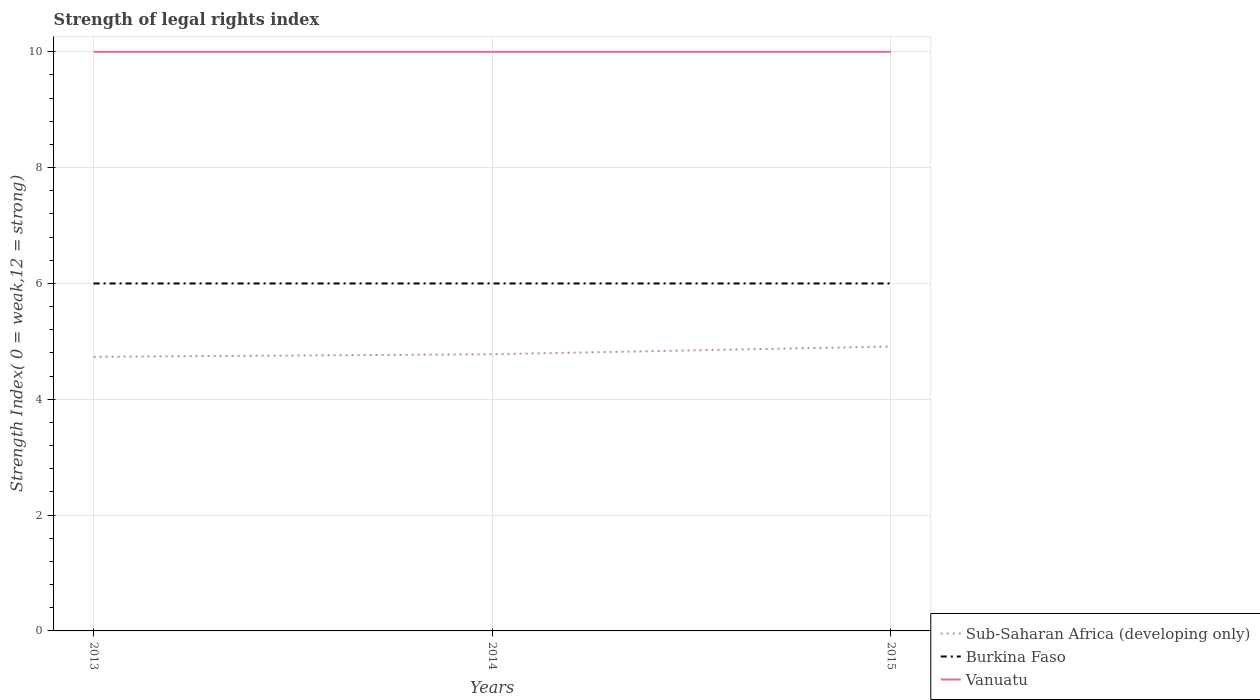Does the line corresponding to Burkina Faso intersect with the line corresponding to Sub-Saharan Africa (developing only)?
Give a very brief answer. No. Is the number of lines equal to the number of legend labels?
Offer a terse response. Yes. In which year was the strength index in Sub-Saharan Africa (developing only) maximum?
Your answer should be compact. 2013. What is the total strength index in Sub-Saharan Africa (developing only) in the graph?
Keep it short and to the point. -0.13. What is the difference between the highest and the second highest strength index in Burkina Faso?
Ensure brevity in your answer.  0. Is the strength index in Burkina Faso strictly greater than the strength index in Sub-Saharan Africa (developing only) over the years?
Provide a succinct answer. No. How many years are there in the graph?
Make the answer very short. 3. What is the difference between two consecutive major ticks on the Y-axis?
Offer a very short reply. 2. Are the values on the major ticks of Y-axis written in scientific E-notation?
Keep it short and to the point. No. Where does the legend appear in the graph?
Your answer should be very brief. Bottom right. How many legend labels are there?
Keep it short and to the point. 3. What is the title of the graph?
Offer a terse response. Strength of legal rights index. Does "Nepal" appear as one of the legend labels in the graph?
Provide a short and direct response. No. What is the label or title of the Y-axis?
Your answer should be very brief. Strength Index( 0 = weak,12 = strong). What is the Strength Index( 0 = weak,12 = strong) of Sub-Saharan Africa (developing only) in 2013?
Your answer should be very brief. 4.73. What is the Strength Index( 0 = weak,12 = strong) of Sub-Saharan Africa (developing only) in 2014?
Make the answer very short. 4.78. What is the Strength Index( 0 = weak,12 = strong) of Burkina Faso in 2014?
Offer a terse response. 6. What is the Strength Index( 0 = weak,12 = strong) of Vanuatu in 2014?
Your response must be concise. 10. What is the Strength Index( 0 = weak,12 = strong) of Sub-Saharan Africa (developing only) in 2015?
Keep it short and to the point. 4.91. What is the Strength Index( 0 = weak,12 = strong) of Burkina Faso in 2015?
Offer a terse response. 6. What is the Strength Index( 0 = weak,12 = strong) of Vanuatu in 2015?
Provide a short and direct response. 10. Across all years, what is the maximum Strength Index( 0 = weak,12 = strong) of Sub-Saharan Africa (developing only)?
Offer a terse response. 4.91. Across all years, what is the maximum Strength Index( 0 = weak,12 = strong) of Vanuatu?
Offer a terse response. 10. Across all years, what is the minimum Strength Index( 0 = weak,12 = strong) of Sub-Saharan Africa (developing only)?
Keep it short and to the point. 4.73. Across all years, what is the minimum Strength Index( 0 = weak,12 = strong) in Burkina Faso?
Ensure brevity in your answer.  6. What is the total Strength Index( 0 = weak,12 = strong) in Sub-Saharan Africa (developing only) in the graph?
Provide a succinct answer. 14.42. What is the total Strength Index( 0 = weak,12 = strong) of Vanuatu in the graph?
Offer a terse response. 30. What is the difference between the Strength Index( 0 = weak,12 = strong) in Sub-Saharan Africa (developing only) in 2013 and that in 2014?
Make the answer very short. -0.04. What is the difference between the Strength Index( 0 = weak,12 = strong) in Burkina Faso in 2013 and that in 2014?
Offer a very short reply. 0. What is the difference between the Strength Index( 0 = weak,12 = strong) of Vanuatu in 2013 and that in 2014?
Provide a succinct answer. 0. What is the difference between the Strength Index( 0 = weak,12 = strong) in Sub-Saharan Africa (developing only) in 2013 and that in 2015?
Offer a terse response. -0.18. What is the difference between the Strength Index( 0 = weak,12 = strong) in Burkina Faso in 2013 and that in 2015?
Your answer should be compact. 0. What is the difference between the Strength Index( 0 = weak,12 = strong) in Vanuatu in 2013 and that in 2015?
Provide a succinct answer. 0. What is the difference between the Strength Index( 0 = weak,12 = strong) of Sub-Saharan Africa (developing only) in 2014 and that in 2015?
Provide a short and direct response. -0.13. What is the difference between the Strength Index( 0 = weak,12 = strong) of Vanuatu in 2014 and that in 2015?
Provide a succinct answer. 0. What is the difference between the Strength Index( 0 = weak,12 = strong) in Sub-Saharan Africa (developing only) in 2013 and the Strength Index( 0 = weak,12 = strong) in Burkina Faso in 2014?
Ensure brevity in your answer.  -1.27. What is the difference between the Strength Index( 0 = weak,12 = strong) in Sub-Saharan Africa (developing only) in 2013 and the Strength Index( 0 = weak,12 = strong) in Vanuatu in 2014?
Offer a very short reply. -5.27. What is the difference between the Strength Index( 0 = weak,12 = strong) of Burkina Faso in 2013 and the Strength Index( 0 = weak,12 = strong) of Vanuatu in 2014?
Give a very brief answer. -4. What is the difference between the Strength Index( 0 = weak,12 = strong) of Sub-Saharan Africa (developing only) in 2013 and the Strength Index( 0 = weak,12 = strong) of Burkina Faso in 2015?
Give a very brief answer. -1.27. What is the difference between the Strength Index( 0 = weak,12 = strong) of Sub-Saharan Africa (developing only) in 2013 and the Strength Index( 0 = weak,12 = strong) of Vanuatu in 2015?
Offer a very short reply. -5.27. What is the difference between the Strength Index( 0 = weak,12 = strong) of Burkina Faso in 2013 and the Strength Index( 0 = weak,12 = strong) of Vanuatu in 2015?
Offer a terse response. -4. What is the difference between the Strength Index( 0 = weak,12 = strong) in Sub-Saharan Africa (developing only) in 2014 and the Strength Index( 0 = weak,12 = strong) in Burkina Faso in 2015?
Your answer should be compact. -1.22. What is the difference between the Strength Index( 0 = weak,12 = strong) of Sub-Saharan Africa (developing only) in 2014 and the Strength Index( 0 = weak,12 = strong) of Vanuatu in 2015?
Your response must be concise. -5.22. What is the difference between the Strength Index( 0 = weak,12 = strong) in Burkina Faso in 2014 and the Strength Index( 0 = weak,12 = strong) in Vanuatu in 2015?
Your answer should be compact. -4. What is the average Strength Index( 0 = weak,12 = strong) in Sub-Saharan Africa (developing only) per year?
Offer a terse response. 4.81. In the year 2013, what is the difference between the Strength Index( 0 = weak,12 = strong) of Sub-Saharan Africa (developing only) and Strength Index( 0 = weak,12 = strong) of Burkina Faso?
Keep it short and to the point. -1.27. In the year 2013, what is the difference between the Strength Index( 0 = weak,12 = strong) of Sub-Saharan Africa (developing only) and Strength Index( 0 = weak,12 = strong) of Vanuatu?
Offer a terse response. -5.27. In the year 2013, what is the difference between the Strength Index( 0 = weak,12 = strong) in Burkina Faso and Strength Index( 0 = weak,12 = strong) in Vanuatu?
Your response must be concise. -4. In the year 2014, what is the difference between the Strength Index( 0 = weak,12 = strong) of Sub-Saharan Africa (developing only) and Strength Index( 0 = weak,12 = strong) of Burkina Faso?
Keep it short and to the point. -1.22. In the year 2014, what is the difference between the Strength Index( 0 = weak,12 = strong) of Sub-Saharan Africa (developing only) and Strength Index( 0 = weak,12 = strong) of Vanuatu?
Ensure brevity in your answer.  -5.22. In the year 2015, what is the difference between the Strength Index( 0 = weak,12 = strong) of Sub-Saharan Africa (developing only) and Strength Index( 0 = weak,12 = strong) of Burkina Faso?
Give a very brief answer. -1.09. In the year 2015, what is the difference between the Strength Index( 0 = weak,12 = strong) of Sub-Saharan Africa (developing only) and Strength Index( 0 = weak,12 = strong) of Vanuatu?
Make the answer very short. -5.09. In the year 2015, what is the difference between the Strength Index( 0 = weak,12 = strong) in Burkina Faso and Strength Index( 0 = weak,12 = strong) in Vanuatu?
Your answer should be compact. -4. What is the ratio of the Strength Index( 0 = weak,12 = strong) of Sub-Saharan Africa (developing only) in 2013 to that in 2014?
Give a very brief answer. 0.99. What is the ratio of the Strength Index( 0 = weak,12 = strong) in Burkina Faso in 2013 to that in 2014?
Your answer should be compact. 1. What is the ratio of the Strength Index( 0 = weak,12 = strong) of Sub-Saharan Africa (developing only) in 2013 to that in 2015?
Your answer should be very brief. 0.96. What is the ratio of the Strength Index( 0 = weak,12 = strong) of Vanuatu in 2013 to that in 2015?
Your answer should be compact. 1. What is the ratio of the Strength Index( 0 = weak,12 = strong) in Sub-Saharan Africa (developing only) in 2014 to that in 2015?
Your answer should be compact. 0.97. What is the ratio of the Strength Index( 0 = weak,12 = strong) of Burkina Faso in 2014 to that in 2015?
Provide a short and direct response. 1. What is the difference between the highest and the second highest Strength Index( 0 = weak,12 = strong) in Sub-Saharan Africa (developing only)?
Keep it short and to the point. 0.13. What is the difference between the highest and the second highest Strength Index( 0 = weak,12 = strong) in Burkina Faso?
Provide a short and direct response. 0. What is the difference between the highest and the lowest Strength Index( 0 = weak,12 = strong) in Sub-Saharan Africa (developing only)?
Your answer should be compact. 0.18. What is the difference between the highest and the lowest Strength Index( 0 = weak,12 = strong) in Burkina Faso?
Provide a short and direct response. 0. What is the difference between the highest and the lowest Strength Index( 0 = weak,12 = strong) of Vanuatu?
Your answer should be very brief. 0. 